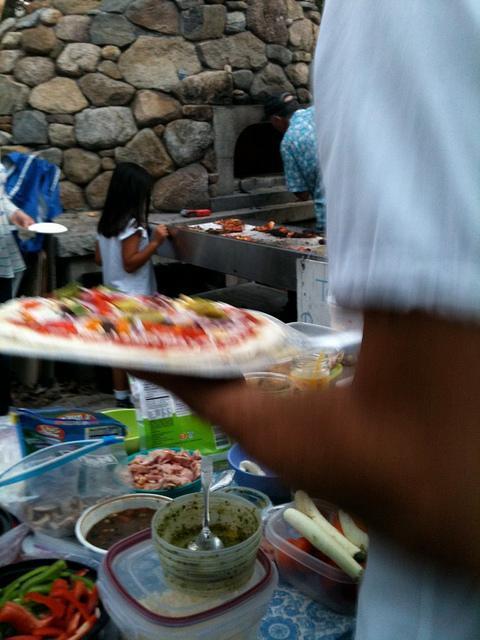How many people are there?
Give a very brief answer. 4. How many pizzas are there?
Give a very brief answer. 1. How many bowls are in the picture?
Give a very brief answer. 2. 